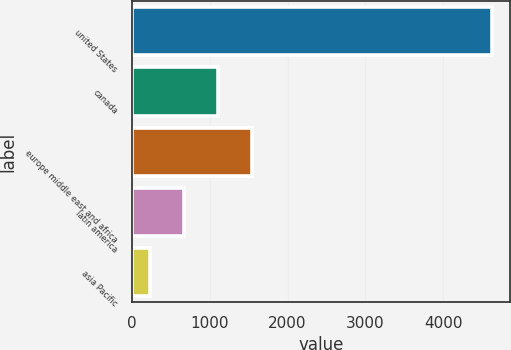<chart> <loc_0><loc_0><loc_500><loc_500><bar_chart><fcel>united States<fcel>canada<fcel>europe middle east and africa<fcel>latin america<fcel>asia Pacific<nl><fcel>4624.3<fcel>1105.98<fcel>1545.77<fcel>666.19<fcel>226.4<nl></chart> 